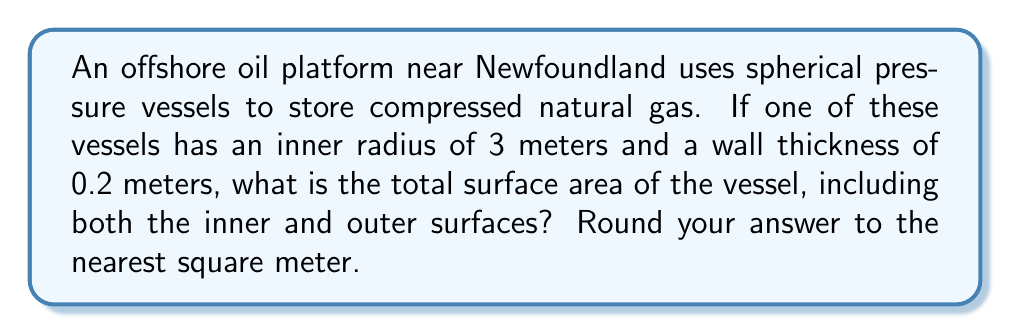Give your solution to this math problem. Let's approach this step-by-step:

1) We need to calculate the surface area of two spheres:
   - The inner sphere with radius $r_i = 3$ m
   - The outer sphere with radius $r_o = 3 + 0.2 = 3.2$ m

2) The formula for the surface area of a sphere is $A = 4\pi r^2$

3) For the inner sphere:
   $A_i = 4\pi r_i^2 = 4\pi (3)^2 = 36\pi$ m²

4) For the outer sphere:
   $A_o = 4\pi r_o^2 = 4\pi (3.2)^2 = 40.96\pi$ m²

5) The total surface area is the sum of both:
   $A_{\text{total}} = A_i + A_o = 36\pi + 40.96\pi = 76.96\pi$ m²

6) Calculate the value:
   $A_{\text{total}} = 76.96 \times 3.14159 \approx 241.785$ m²

7) Rounding to the nearest square meter:
   $A_{\text{total}} \approx 242$ m²
Answer: 242 m² 